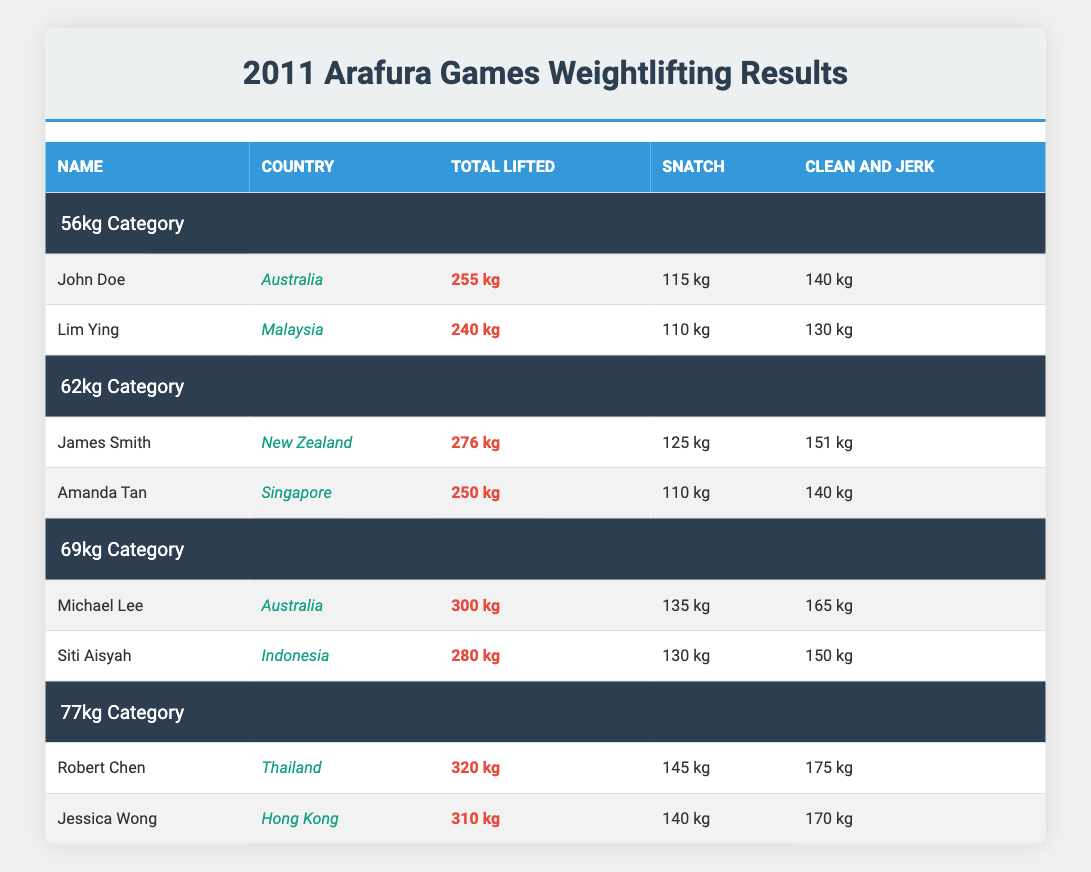What was the total weight lifted by Robert Chen? The table lists Robert Chen under the 77kg category, and the Total Lifted for him is displayed as 320 kg.
Answer: 320 kg Who lifted the highest weight in the 56kg category? Reviewing the 56kg category, John Doe lifted a total of 255 kg, which is higher than Lim Ying's 240 kg, making John Doe the highest in this category.
Answer: John Doe What is the total weight lifted by athletes in the 69kg category? The total lifted by Michael Lee is 300 kg and by Siti Aisyah is 280 kg. Adding both gives 300 + 280 = 580 kg for the 69kg category.
Answer: 580 kg Did Amanda Tan lift more than 260 kg? In the table, Amanda Tan's total lifted weight is 250 kg, which is less than 260 kg. Thus, she did not lift more than 260 kg.
Answer: No Which country did the athlete with the second highest total lift belong to? The second highest lifted weight is by Jessica Wong, who lifted 310 kg, representing Hong Kong. Thus, the country is Hong Kong.
Answer: Hong Kong What is the average Total Lifted for the athletes in the 77kg category? Robert Chen lifted 320 kg and Jessica Wong lifted 310 kg. The sum is 320 + 310 = 630 kg. There are 2 athletes, so the average is 630/2 = 315 kg.
Answer: 315 kg Did any athlete in the 62kg category have a Clean and Jerk lift greater than 145 kg? In the 62kg category, James Smith's Clean and Jerk is 151 kg, which is greater than 145 kg. Therefore, the statement is true.
Answer: Yes Who had a higher Snatch lift, Siti Aisyah or John Doe? Siti Aisyah lifted 130 kg in Snatch while John Doe lifted 115 kg. Therefore, Siti Aisyah had a higher Snatch lift.
Answer: Siti Aisyah 